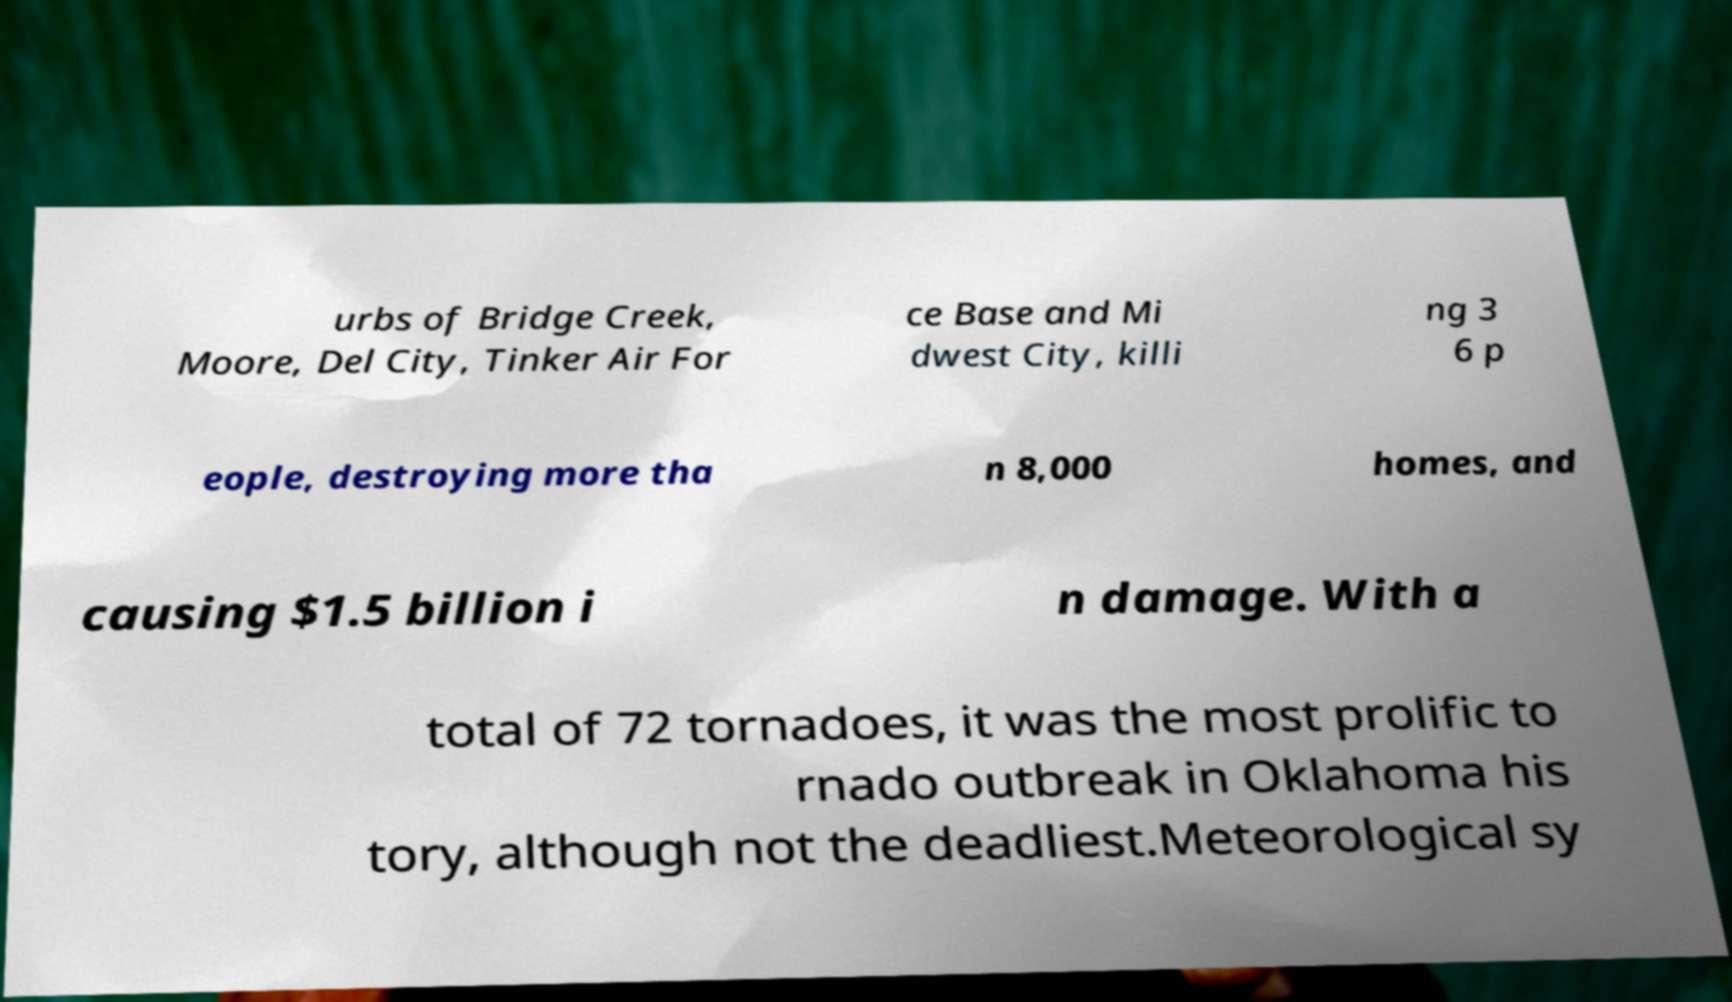I need the written content from this picture converted into text. Can you do that? urbs of Bridge Creek, Moore, Del City, Tinker Air For ce Base and Mi dwest City, killi ng 3 6 p eople, destroying more tha n 8,000 homes, and causing $1.5 billion i n damage. With a total of 72 tornadoes, it was the most prolific to rnado outbreak in Oklahoma his tory, although not the deadliest.Meteorological sy 